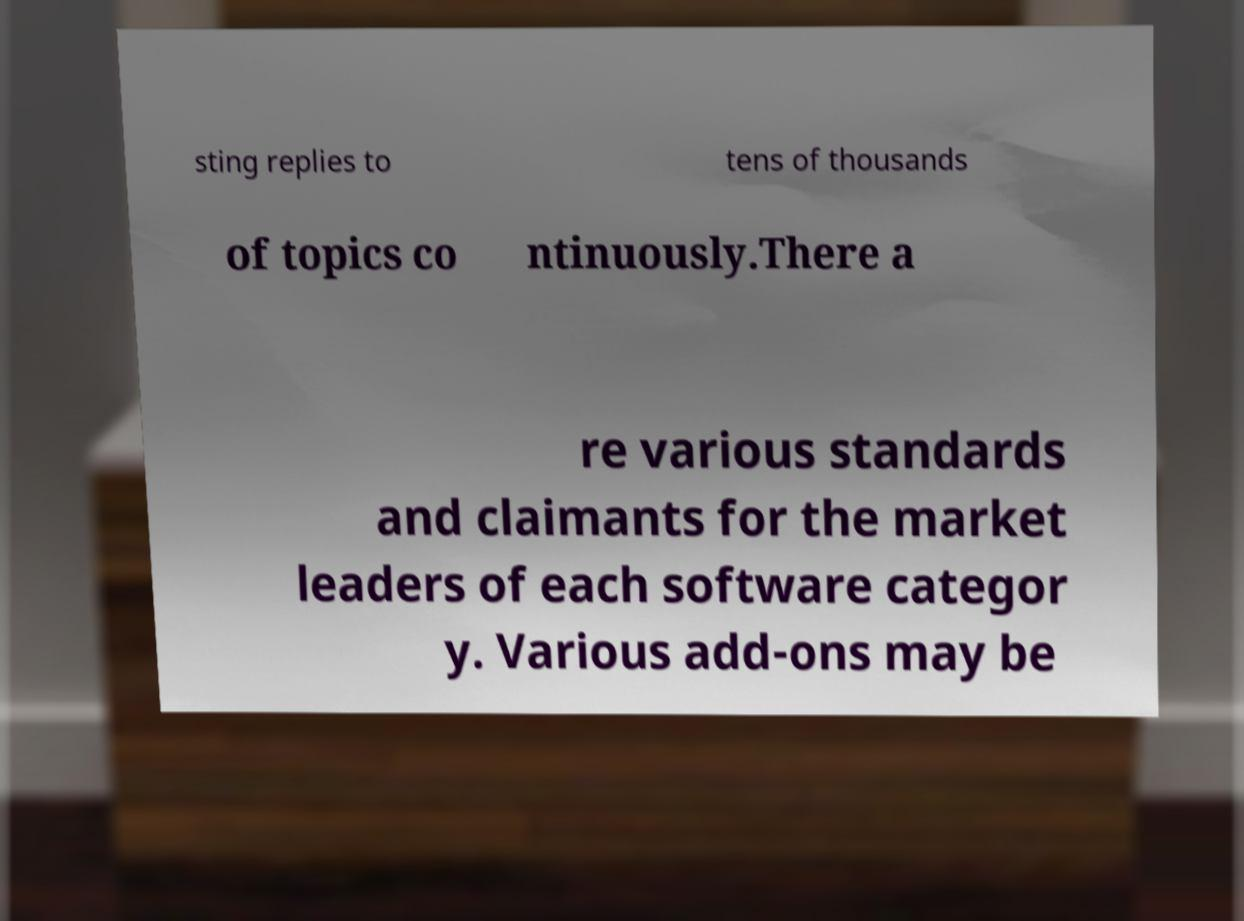Could you assist in decoding the text presented in this image and type it out clearly? sting replies to tens of thousands of topics co ntinuously.There a re various standards and claimants for the market leaders of each software categor y. Various add-ons may be 